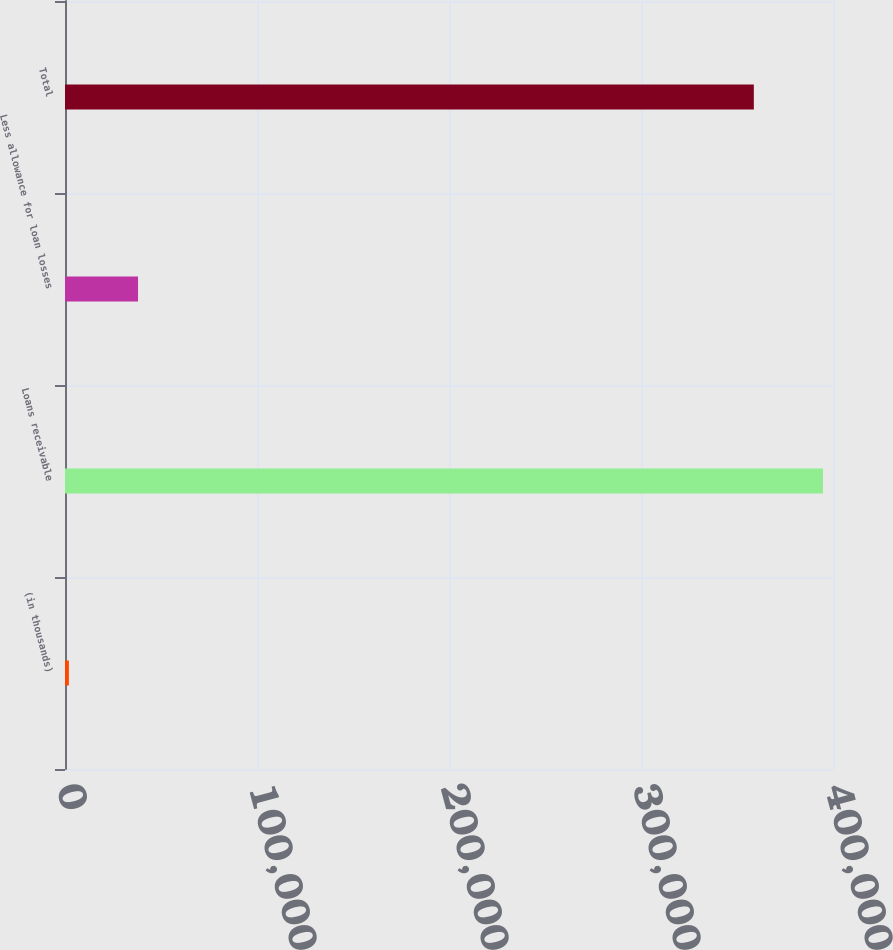Convert chart. <chart><loc_0><loc_0><loc_500><loc_500><bar_chart><fcel>(in thousands)<fcel>Loans receivable<fcel>Less allowance for loan losses<fcel>Total<nl><fcel>2010<fcel>394794<fcel>38038.5<fcel>358766<nl></chart> 